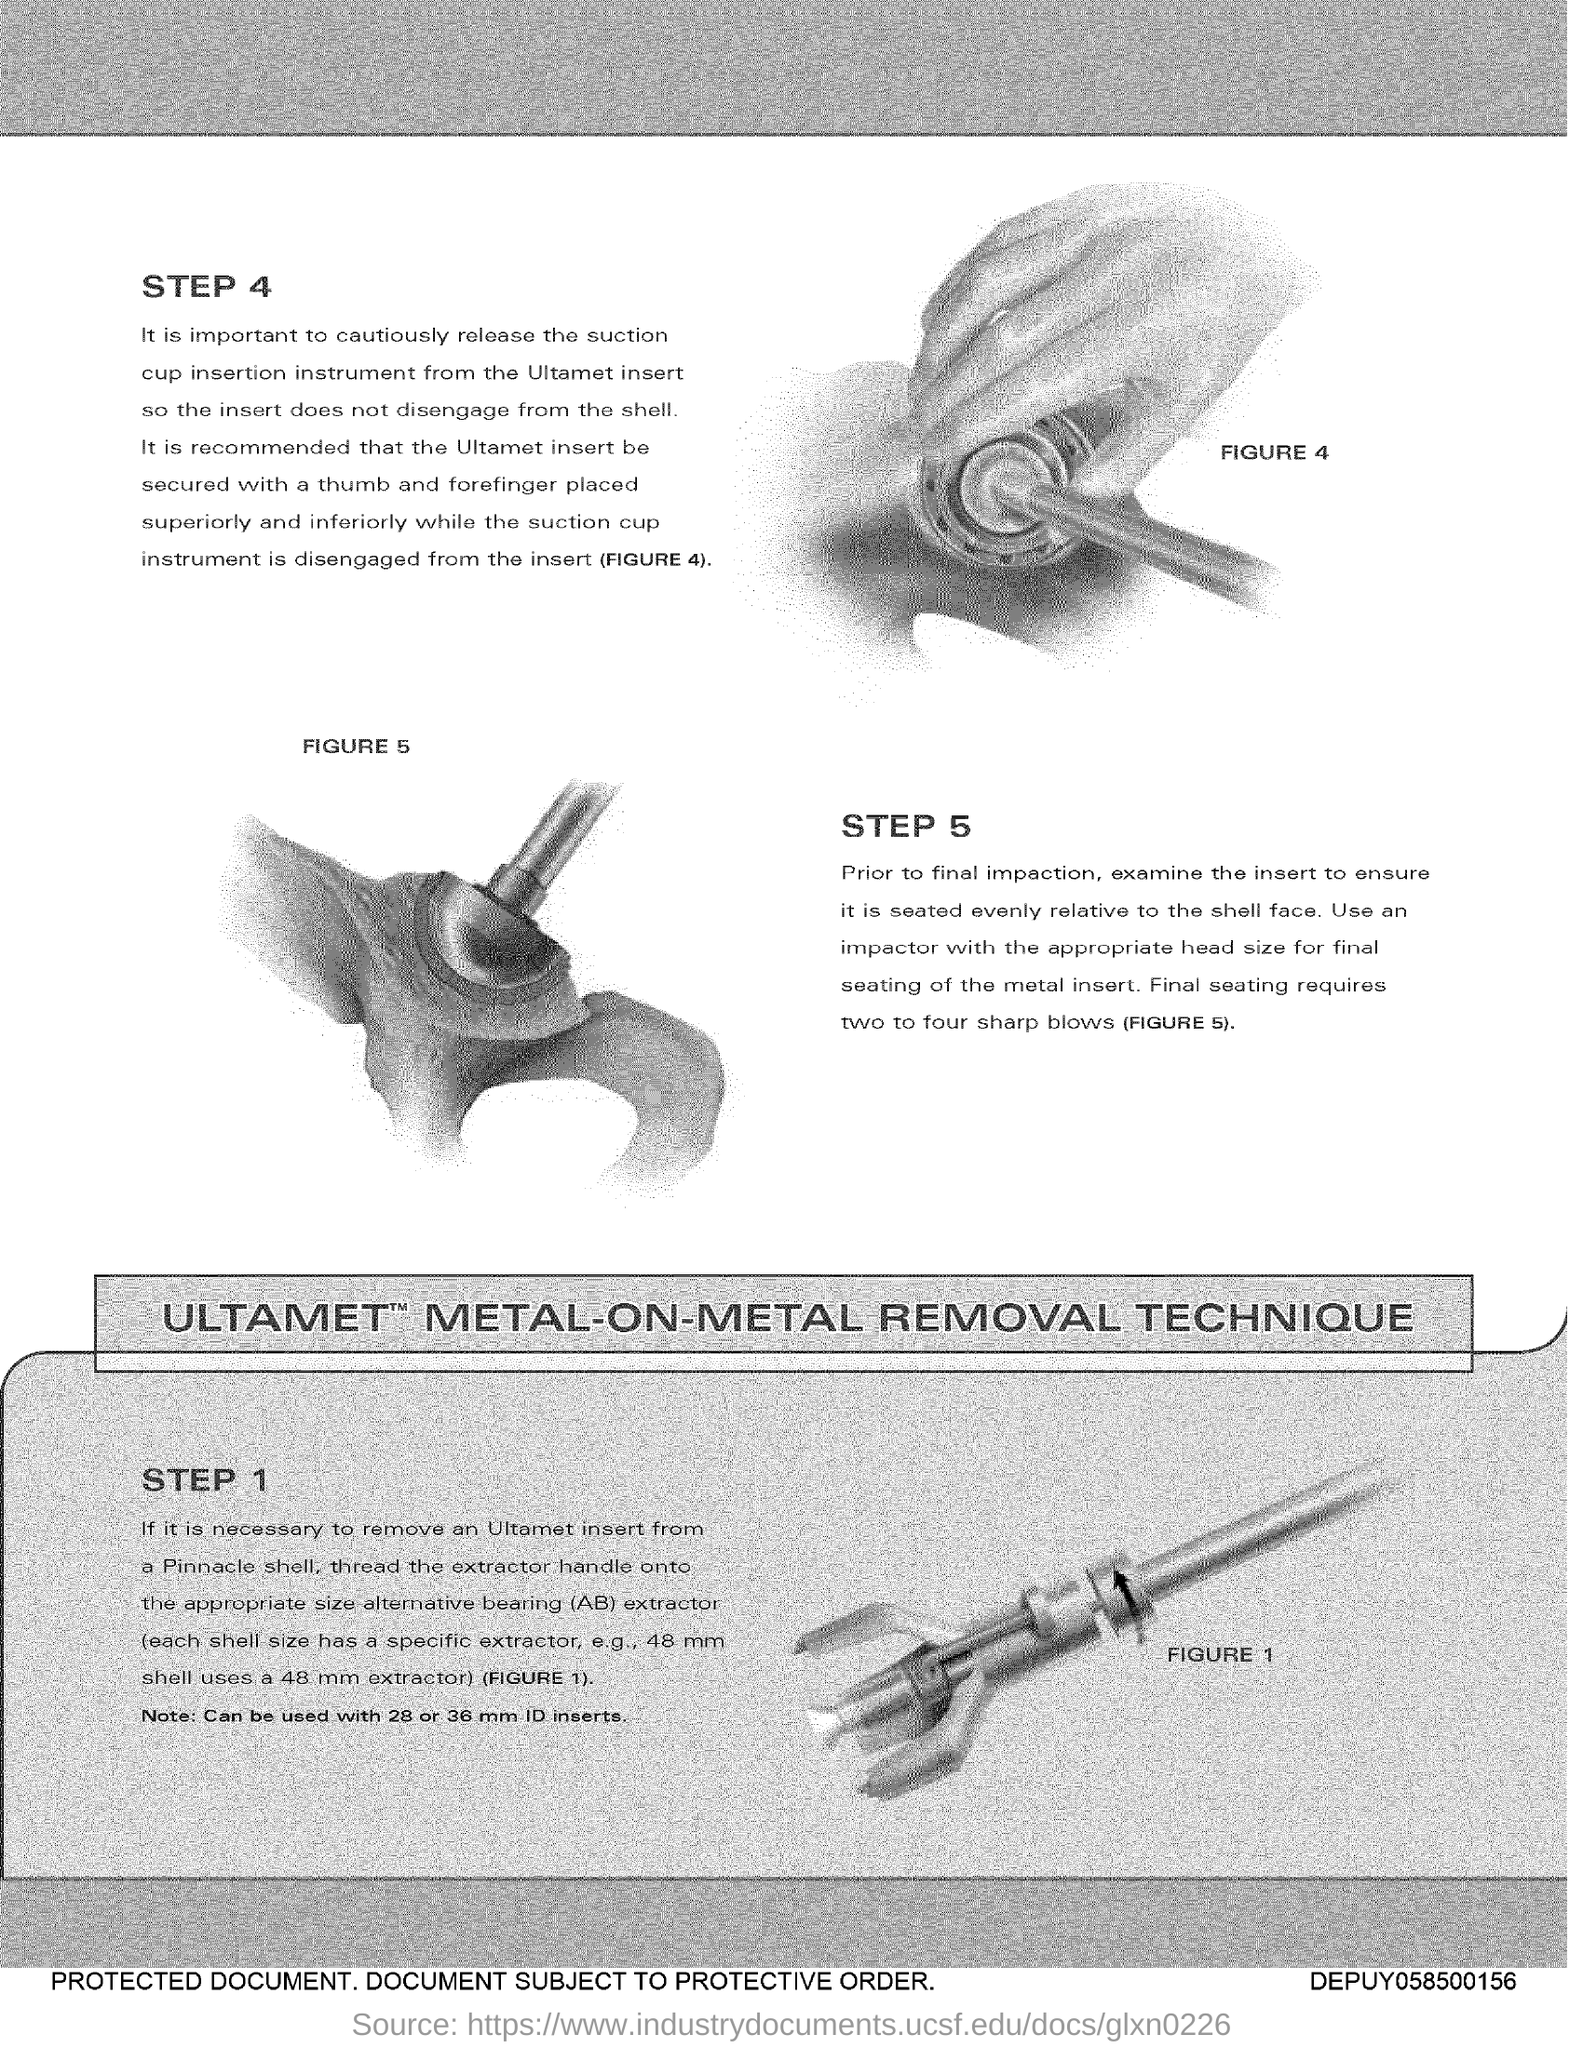Outline some significant characteristics in this image. The text written above the left side figure in Figure 5 is... 